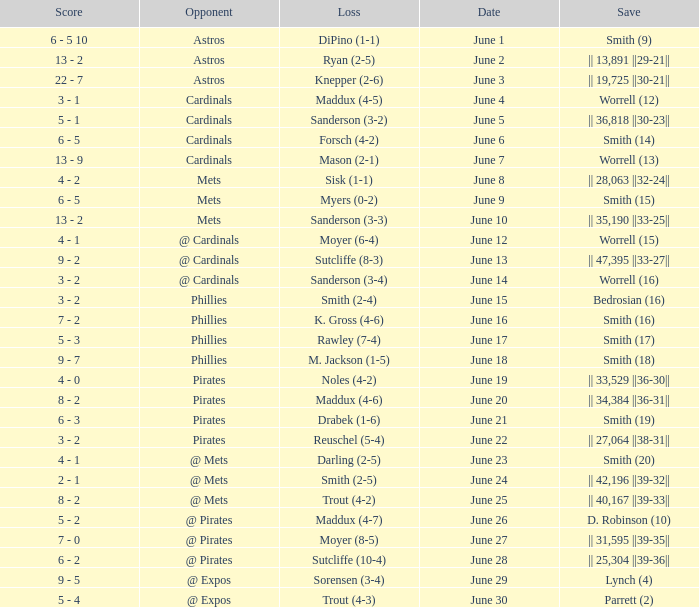On which day did the Chicago Cubs have a loss of trout (4-2)? June 25. 